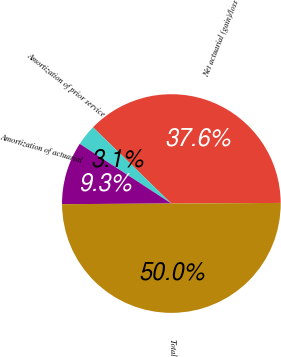Convert chart. <chart><loc_0><loc_0><loc_500><loc_500><pie_chart><fcel>Net actuarial (gain)/loss<fcel>Amortization of prior service<fcel>Amortization of actuarial<fcel>Total<nl><fcel>37.63%<fcel>3.09%<fcel>9.28%<fcel>50.0%<nl></chart> 